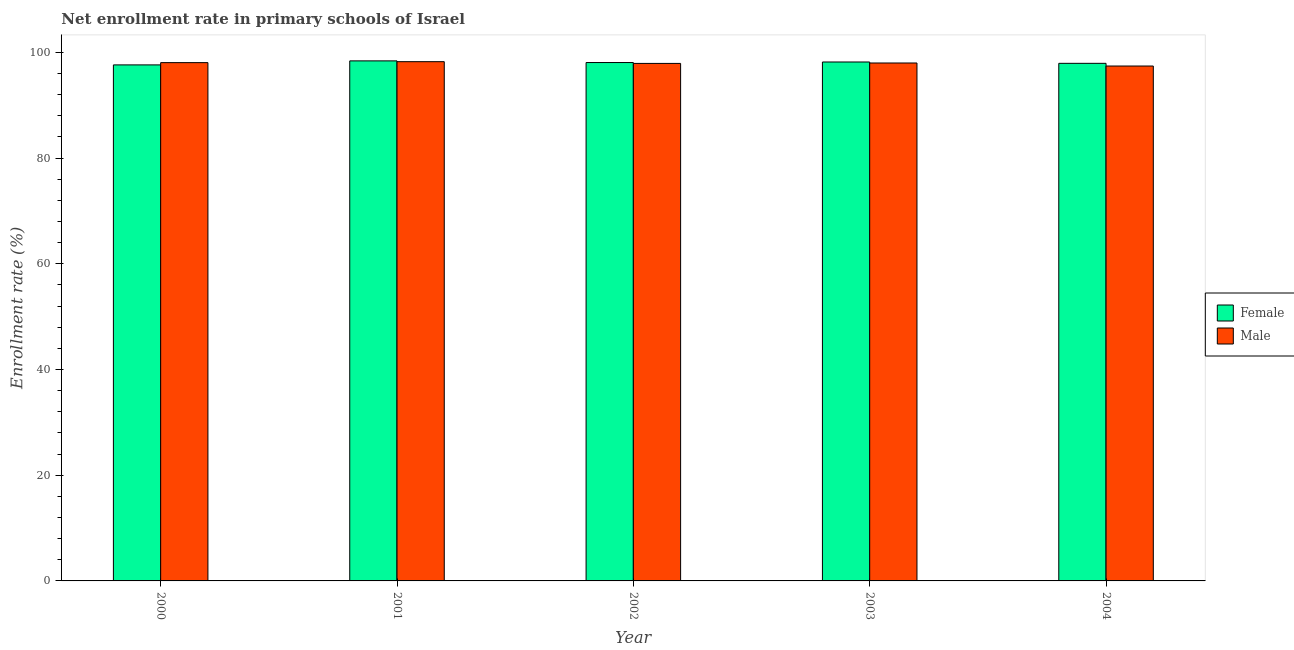How many different coloured bars are there?
Offer a terse response. 2. Are the number of bars per tick equal to the number of legend labels?
Provide a succinct answer. Yes. How many bars are there on the 2nd tick from the left?
Your answer should be compact. 2. How many bars are there on the 1st tick from the right?
Provide a succinct answer. 2. What is the label of the 4th group of bars from the left?
Your answer should be compact. 2003. What is the enrollment rate of female students in 2003?
Ensure brevity in your answer.  98.18. Across all years, what is the maximum enrollment rate of female students?
Make the answer very short. 98.39. Across all years, what is the minimum enrollment rate of female students?
Offer a terse response. 97.63. In which year was the enrollment rate of male students minimum?
Provide a short and direct response. 2004. What is the total enrollment rate of male students in the graph?
Ensure brevity in your answer.  489.6. What is the difference between the enrollment rate of female students in 2000 and that in 2001?
Ensure brevity in your answer.  -0.76. What is the difference between the enrollment rate of female students in 2000 and the enrollment rate of male students in 2002?
Make the answer very short. -0.45. What is the average enrollment rate of male students per year?
Keep it short and to the point. 97.92. In how many years, is the enrollment rate of male students greater than 60 %?
Provide a short and direct response. 5. What is the ratio of the enrollment rate of female students in 2000 to that in 2002?
Give a very brief answer. 1. Is the enrollment rate of male students in 2000 less than that in 2004?
Offer a very short reply. No. Is the difference between the enrollment rate of female students in 2002 and 2003 greater than the difference between the enrollment rate of male students in 2002 and 2003?
Provide a short and direct response. No. What is the difference between the highest and the second highest enrollment rate of female students?
Offer a terse response. 0.21. What is the difference between the highest and the lowest enrollment rate of male students?
Give a very brief answer. 0.82. In how many years, is the enrollment rate of male students greater than the average enrollment rate of male students taken over all years?
Your answer should be compact. 3. Is the sum of the enrollment rate of male students in 2000 and 2002 greater than the maximum enrollment rate of female students across all years?
Your answer should be very brief. Yes. What does the 1st bar from the left in 2004 represents?
Offer a very short reply. Female. Are the values on the major ticks of Y-axis written in scientific E-notation?
Your response must be concise. No. Does the graph contain any zero values?
Provide a succinct answer. No. What is the title of the graph?
Provide a succinct answer. Net enrollment rate in primary schools of Israel. Does "Public funds" appear as one of the legend labels in the graph?
Your answer should be compact. No. What is the label or title of the X-axis?
Provide a short and direct response. Year. What is the label or title of the Y-axis?
Make the answer very short. Enrollment rate (%). What is the Enrollment rate (%) in Female in 2000?
Offer a very short reply. 97.63. What is the Enrollment rate (%) of Male in 2000?
Ensure brevity in your answer.  98.06. What is the Enrollment rate (%) of Female in 2001?
Provide a short and direct response. 98.39. What is the Enrollment rate (%) of Male in 2001?
Ensure brevity in your answer.  98.24. What is the Enrollment rate (%) in Female in 2002?
Make the answer very short. 98.08. What is the Enrollment rate (%) of Male in 2002?
Offer a very short reply. 97.91. What is the Enrollment rate (%) in Female in 2003?
Your answer should be compact. 98.18. What is the Enrollment rate (%) in Male in 2003?
Ensure brevity in your answer.  97.99. What is the Enrollment rate (%) in Female in 2004?
Provide a short and direct response. 97.93. What is the Enrollment rate (%) of Male in 2004?
Offer a terse response. 97.42. Across all years, what is the maximum Enrollment rate (%) in Female?
Keep it short and to the point. 98.39. Across all years, what is the maximum Enrollment rate (%) of Male?
Offer a very short reply. 98.24. Across all years, what is the minimum Enrollment rate (%) in Female?
Your answer should be compact. 97.63. Across all years, what is the minimum Enrollment rate (%) of Male?
Ensure brevity in your answer.  97.42. What is the total Enrollment rate (%) of Female in the graph?
Provide a short and direct response. 490.19. What is the total Enrollment rate (%) in Male in the graph?
Provide a short and direct response. 489.6. What is the difference between the Enrollment rate (%) of Female in 2000 and that in 2001?
Give a very brief answer. -0.76. What is the difference between the Enrollment rate (%) in Male in 2000 and that in 2001?
Offer a terse response. -0.18. What is the difference between the Enrollment rate (%) of Female in 2000 and that in 2002?
Your answer should be very brief. -0.45. What is the difference between the Enrollment rate (%) of Male in 2000 and that in 2002?
Ensure brevity in your answer.  0.15. What is the difference between the Enrollment rate (%) in Female in 2000 and that in 2003?
Your answer should be compact. -0.55. What is the difference between the Enrollment rate (%) of Male in 2000 and that in 2003?
Keep it short and to the point. 0.07. What is the difference between the Enrollment rate (%) in Female in 2000 and that in 2004?
Your answer should be very brief. -0.3. What is the difference between the Enrollment rate (%) in Male in 2000 and that in 2004?
Keep it short and to the point. 0.64. What is the difference between the Enrollment rate (%) of Female in 2001 and that in 2002?
Give a very brief answer. 0.31. What is the difference between the Enrollment rate (%) in Male in 2001 and that in 2002?
Offer a very short reply. 0.33. What is the difference between the Enrollment rate (%) in Female in 2001 and that in 2003?
Your answer should be very brief. 0.21. What is the difference between the Enrollment rate (%) of Male in 2001 and that in 2003?
Your response must be concise. 0.25. What is the difference between the Enrollment rate (%) of Female in 2001 and that in 2004?
Your answer should be very brief. 0.46. What is the difference between the Enrollment rate (%) of Male in 2001 and that in 2004?
Give a very brief answer. 0.82. What is the difference between the Enrollment rate (%) of Female in 2002 and that in 2003?
Your response must be concise. -0.1. What is the difference between the Enrollment rate (%) in Male in 2002 and that in 2003?
Offer a terse response. -0.08. What is the difference between the Enrollment rate (%) of Female in 2002 and that in 2004?
Offer a terse response. 0.15. What is the difference between the Enrollment rate (%) in Male in 2002 and that in 2004?
Provide a succinct answer. 0.49. What is the difference between the Enrollment rate (%) of Female in 2003 and that in 2004?
Offer a very short reply. 0.25. What is the difference between the Enrollment rate (%) in Male in 2003 and that in 2004?
Your response must be concise. 0.57. What is the difference between the Enrollment rate (%) of Female in 2000 and the Enrollment rate (%) of Male in 2001?
Offer a terse response. -0.61. What is the difference between the Enrollment rate (%) in Female in 2000 and the Enrollment rate (%) in Male in 2002?
Provide a succinct answer. -0.28. What is the difference between the Enrollment rate (%) of Female in 2000 and the Enrollment rate (%) of Male in 2003?
Your answer should be compact. -0.36. What is the difference between the Enrollment rate (%) in Female in 2000 and the Enrollment rate (%) in Male in 2004?
Ensure brevity in your answer.  0.21. What is the difference between the Enrollment rate (%) of Female in 2001 and the Enrollment rate (%) of Male in 2002?
Ensure brevity in your answer.  0.48. What is the difference between the Enrollment rate (%) of Female in 2001 and the Enrollment rate (%) of Male in 2003?
Make the answer very short. 0.4. What is the difference between the Enrollment rate (%) in Female in 2001 and the Enrollment rate (%) in Male in 2004?
Keep it short and to the point. 0.97. What is the difference between the Enrollment rate (%) in Female in 2002 and the Enrollment rate (%) in Male in 2003?
Make the answer very short. 0.09. What is the difference between the Enrollment rate (%) of Female in 2002 and the Enrollment rate (%) of Male in 2004?
Your answer should be very brief. 0.66. What is the difference between the Enrollment rate (%) in Female in 2003 and the Enrollment rate (%) in Male in 2004?
Provide a short and direct response. 0.76. What is the average Enrollment rate (%) of Female per year?
Keep it short and to the point. 98.04. What is the average Enrollment rate (%) of Male per year?
Make the answer very short. 97.92. In the year 2000, what is the difference between the Enrollment rate (%) of Female and Enrollment rate (%) of Male?
Offer a terse response. -0.43. In the year 2001, what is the difference between the Enrollment rate (%) of Female and Enrollment rate (%) of Male?
Provide a succinct answer. 0.15. In the year 2002, what is the difference between the Enrollment rate (%) of Female and Enrollment rate (%) of Male?
Offer a terse response. 0.17. In the year 2003, what is the difference between the Enrollment rate (%) of Female and Enrollment rate (%) of Male?
Your answer should be very brief. 0.19. In the year 2004, what is the difference between the Enrollment rate (%) in Female and Enrollment rate (%) in Male?
Give a very brief answer. 0.51. What is the ratio of the Enrollment rate (%) in Male in 2000 to that in 2001?
Provide a short and direct response. 1. What is the ratio of the Enrollment rate (%) of Male in 2000 to that in 2002?
Offer a terse response. 1. What is the ratio of the Enrollment rate (%) in Male in 2000 to that in 2003?
Offer a terse response. 1. What is the ratio of the Enrollment rate (%) of Male in 2000 to that in 2004?
Offer a very short reply. 1.01. What is the ratio of the Enrollment rate (%) in Female in 2001 to that in 2002?
Offer a very short reply. 1. What is the ratio of the Enrollment rate (%) in Male in 2001 to that in 2003?
Your answer should be very brief. 1. What is the ratio of the Enrollment rate (%) of Male in 2001 to that in 2004?
Your response must be concise. 1.01. What is the ratio of the Enrollment rate (%) in Female in 2002 to that in 2003?
Ensure brevity in your answer.  1. What is the ratio of the Enrollment rate (%) of Female in 2002 to that in 2004?
Your response must be concise. 1. What is the ratio of the Enrollment rate (%) of Female in 2003 to that in 2004?
Give a very brief answer. 1. What is the ratio of the Enrollment rate (%) in Male in 2003 to that in 2004?
Your answer should be very brief. 1.01. What is the difference between the highest and the second highest Enrollment rate (%) of Female?
Give a very brief answer. 0.21. What is the difference between the highest and the second highest Enrollment rate (%) of Male?
Ensure brevity in your answer.  0.18. What is the difference between the highest and the lowest Enrollment rate (%) of Female?
Your response must be concise. 0.76. What is the difference between the highest and the lowest Enrollment rate (%) in Male?
Make the answer very short. 0.82. 